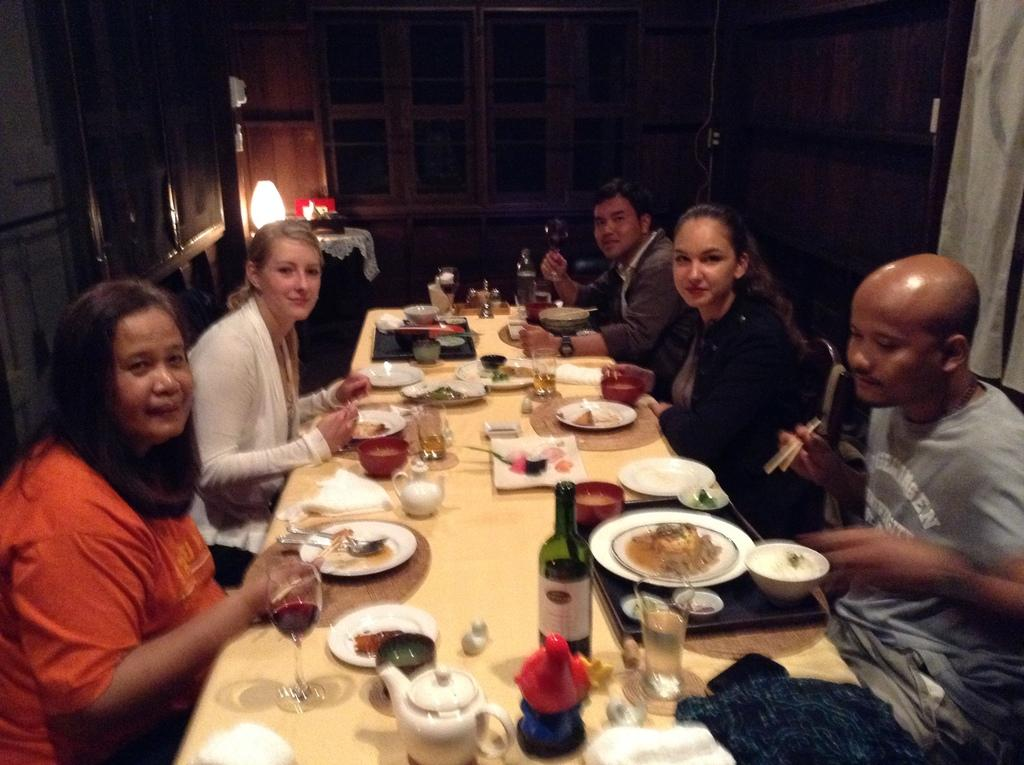How many people are present in the image? There is a group of five people in the image. What activity are the people engaged in? The people are having dinner. Where is the dinner taking place? The dinner is taking place at a dining table. What is the average income of the people in the image? There is no information about the income of the people in the image. How many eyes can be seen in the image? The number of eyes cannot be determined from the image, as it only shows a group of people from a distance. 